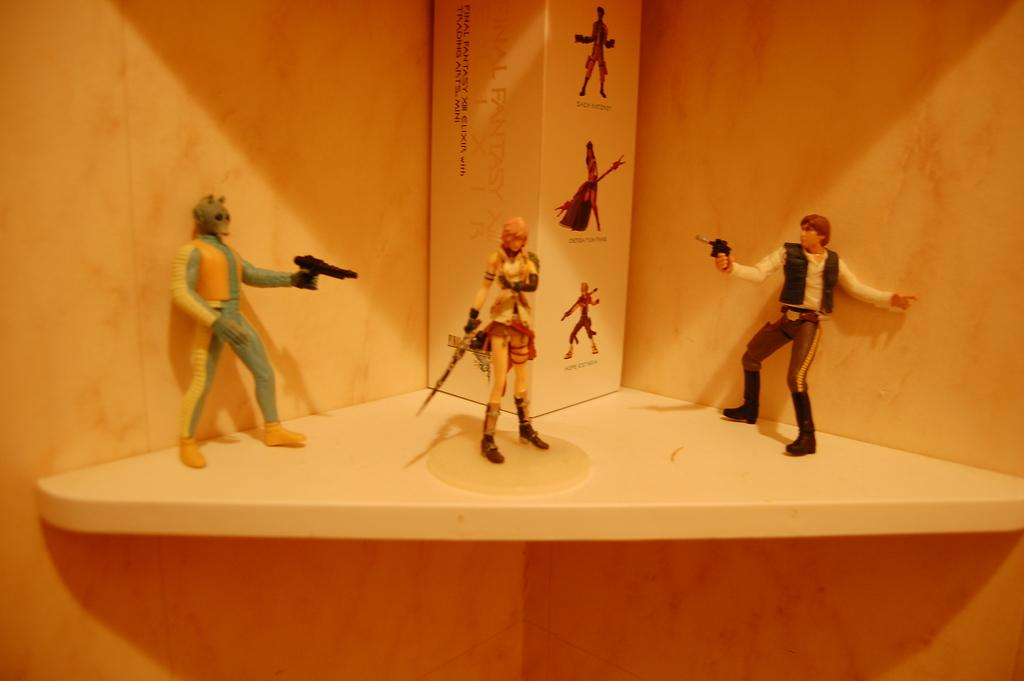What is the primary color of the surface in the image? The surface in the image is white. What object is placed on the white surface? There is a box on the white surface. What other items can be seen on the white surface? There are toys on the white surface. What are the toys doing in the image? The toys are holding weapons. What can be seen in the background of the image? There are walls visible in the background of the image. Can you tell me how many ghosts are visible in the image? There are no ghosts present in the image. What shape is the cable in the image? There is no cable present in the image. 